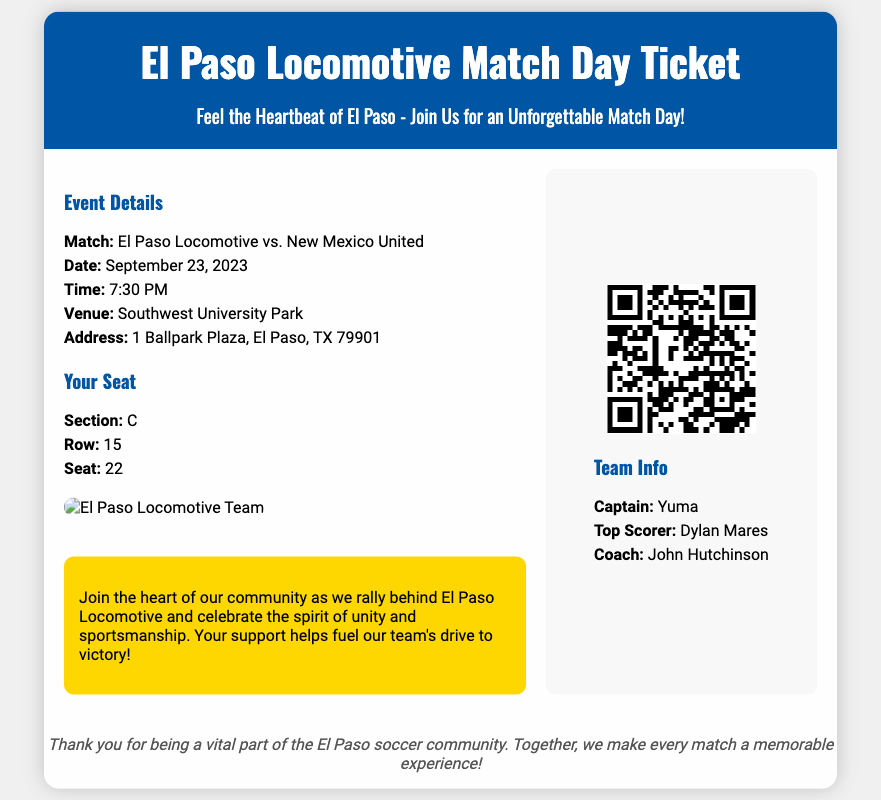What is the match date? The match date is provided in the event details section of the document.
Answer: September 23, 2023 What is the venue name? The venue name is listed under the event details section.
Answer: Southwest University Park Who is the top scorer? The top scorer's name is mentioned in the team info section of the document.
Answer: Dylan Mares What is the seat number? The seat number is specified in the seat info section of the document.
Answer: 22 What is the QR code used for? The QR code is used for scanning to access ticket information.
Answer: Access ticket information What section is the seat located in? The section location is provided in the seat info section, indicating where the seat is.
Answer: C How many items are listed under the event details? The event details section contains a list comprised of five specific items listed.
Answer: five Who is the captain of the team? The captain's name is provided in the team info section of the document.
Answer: Yuma What message is prominently displayed? The message in the ticket header emphasizes the spirit of the match day experience.
Answer: Feel the Heartbeat of El Paso - Join Us for an Unforgettable Match Day! 